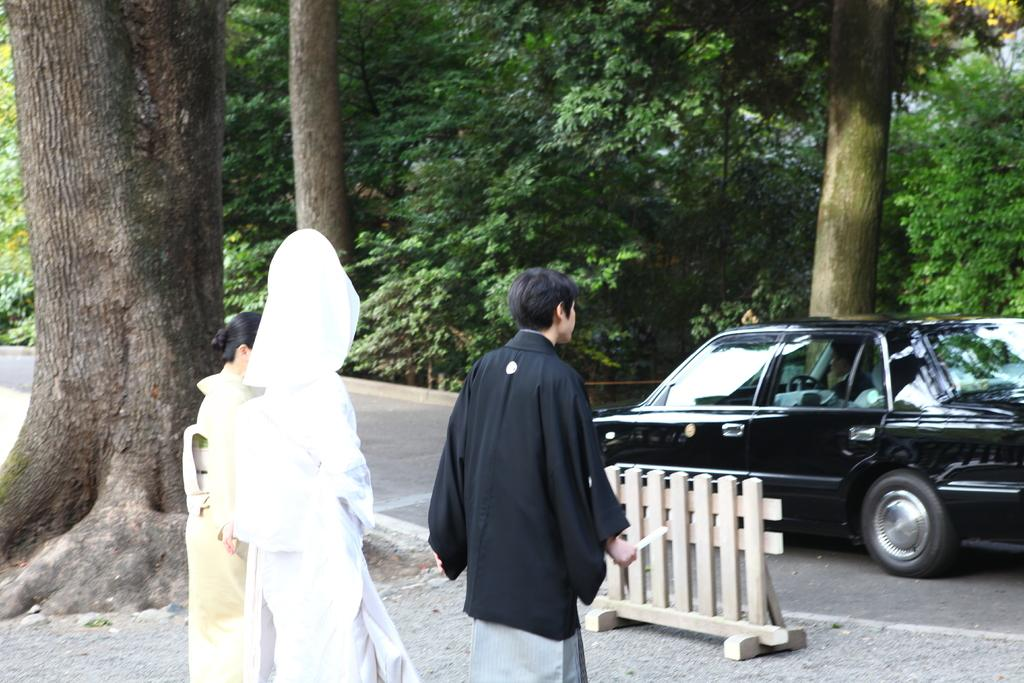How many people are in the image? There are three people in the image. Where are the people located in the image? The people are standing on a road. What else can be seen on the road in the image? There is a car parked on the road. What type of natural scenery is visible in the image? There are trees visible in the image. Can you see any sheep jumping over the car in the image? There are no sheep or jumping activities present in the image. 